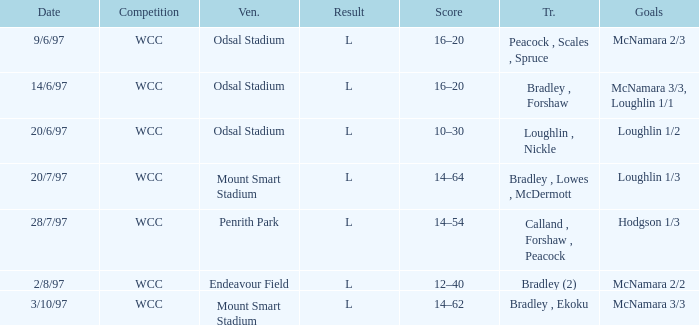What was the score on 20/6/97? 10–30. 